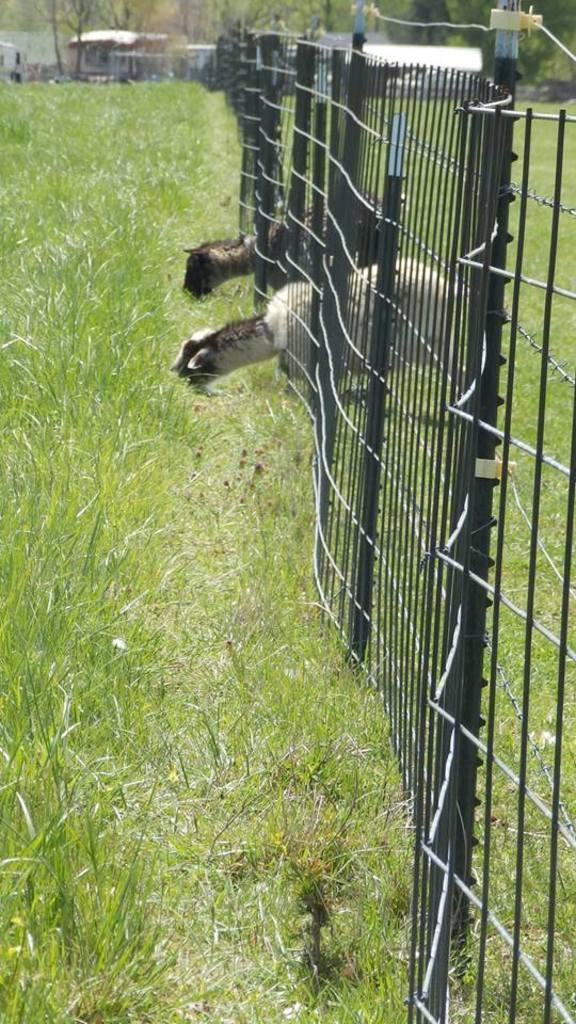Can you describe this image briefly? In this picture we can see two animals are eating grass. We can see some fencing on the right side. There are few houses and trees in the background. 